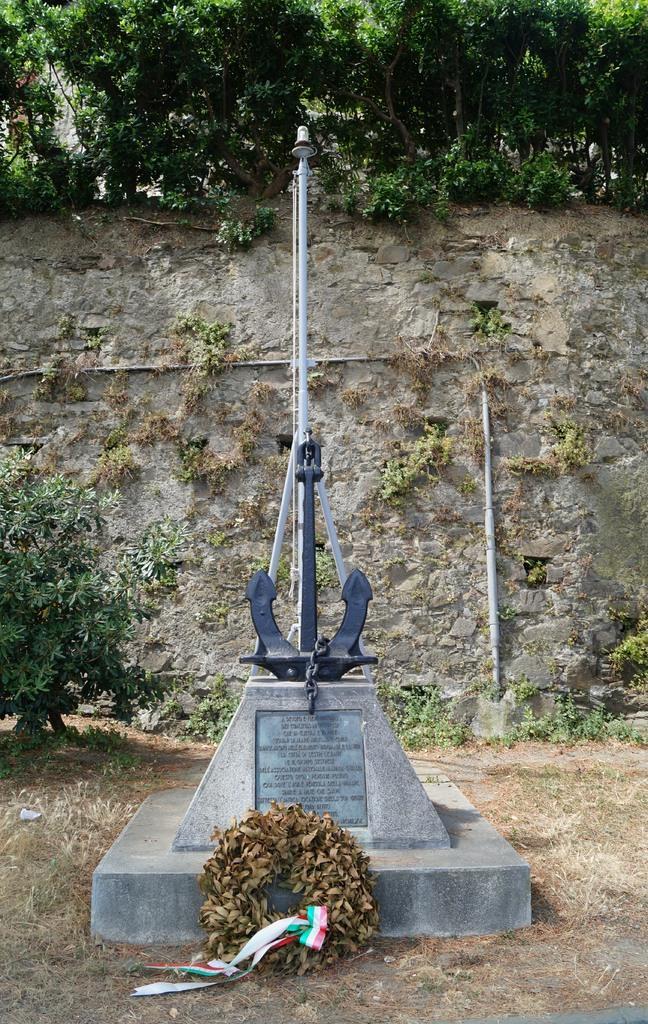In one or two sentences, can you explain what this image depicts? In this image, in the middle, we can see a sculpture. On the sculpture, we can also see a garland. On the left side, we can see a plant. In the background, we can see a wall. At the top, we can see a sky, at the bottom, we can see a grass and a few plants. 